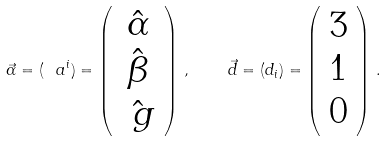<formula> <loc_0><loc_0><loc_500><loc_500>\vec { \alpha } = ( \ a ^ { i } ) = \left ( \begin{array} { c } \hat { \alpha } \\ \hat { \beta } \\ \hat { \ g } \\ \end{array} \right ) \, , \quad \vec { d } = ( d _ { i } ) = \left ( \begin{array} { c } 3 \\ 1 \\ 0 \\ \end{array} \right ) \, .</formula> 